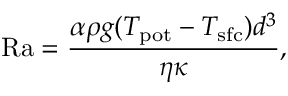<formula> <loc_0><loc_0><loc_500><loc_500>R a = \frac { \alpha \rho g ( T _ { p o t } - T _ { s f c } ) d ^ { 3 } } { \eta \kappa } ,</formula> 